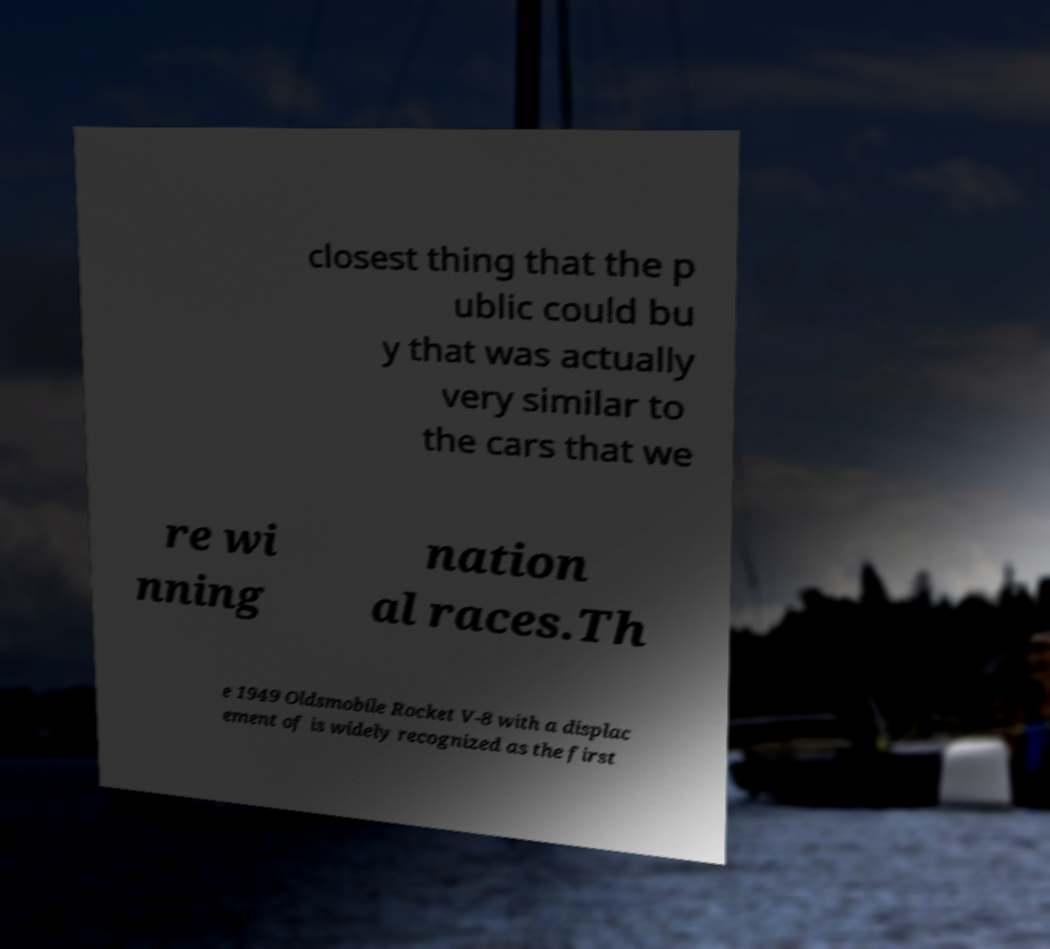Could you extract and type out the text from this image? closest thing that the p ublic could bu y that was actually very similar to the cars that we re wi nning nation al races.Th e 1949 Oldsmobile Rocket V-8 with a displac ement of is widely recognized as the first 